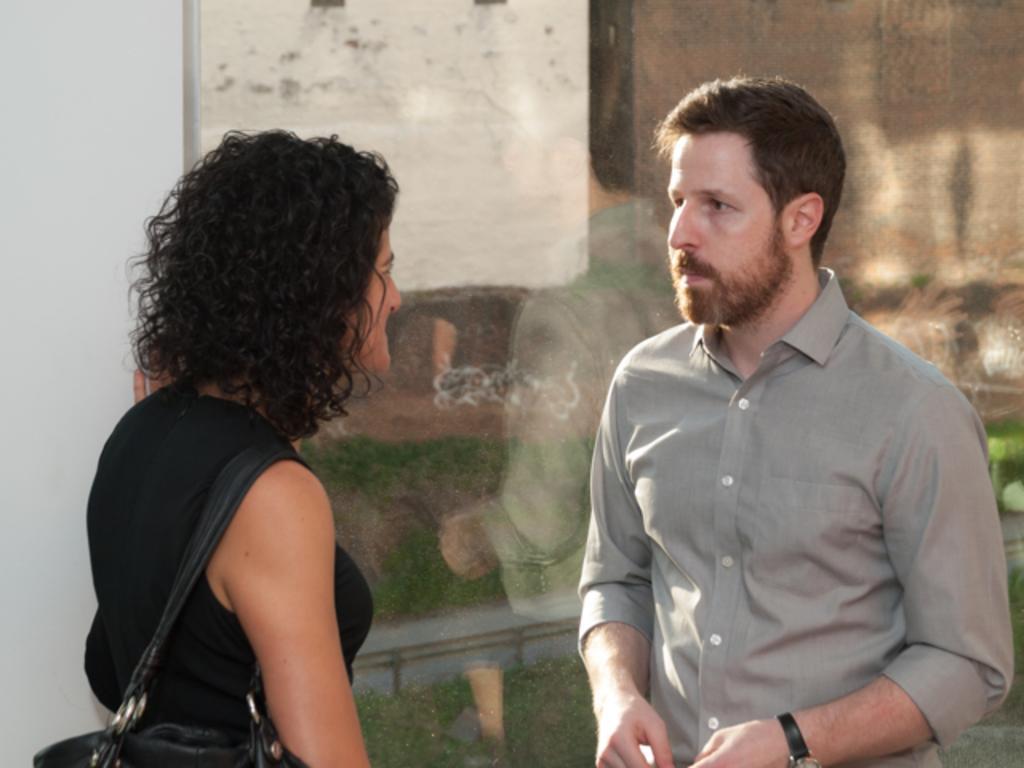Could you give a brief overview of what you see in this image? In this picture, we can see a few people, and in the background we can see the glass and some reflections on the glass. 